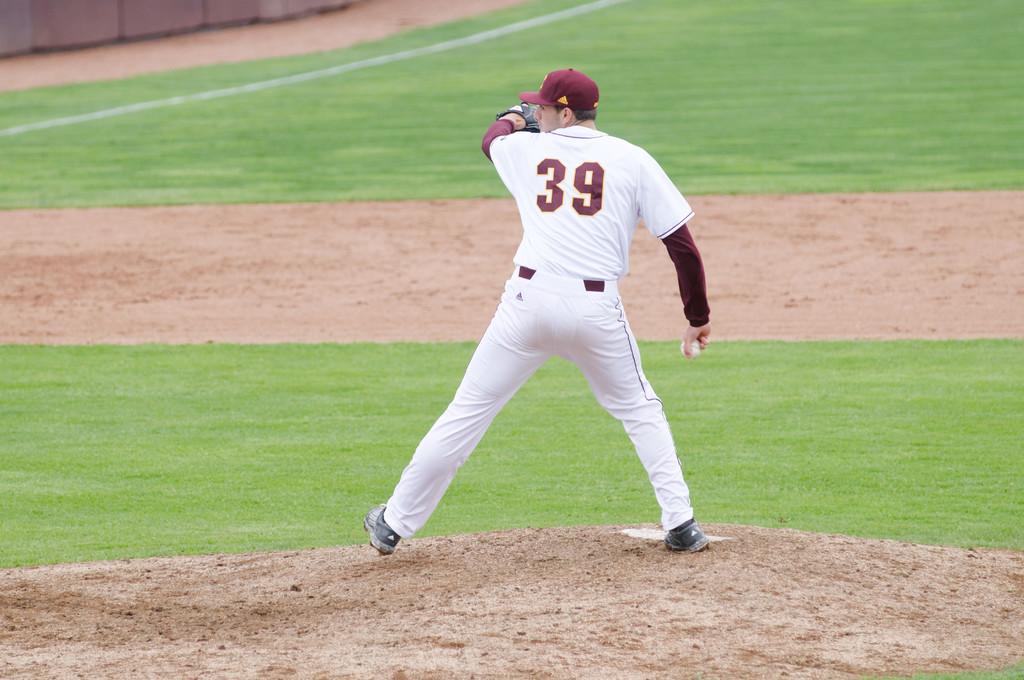What number is the pitcher?
Offer a very short reply. 39. 